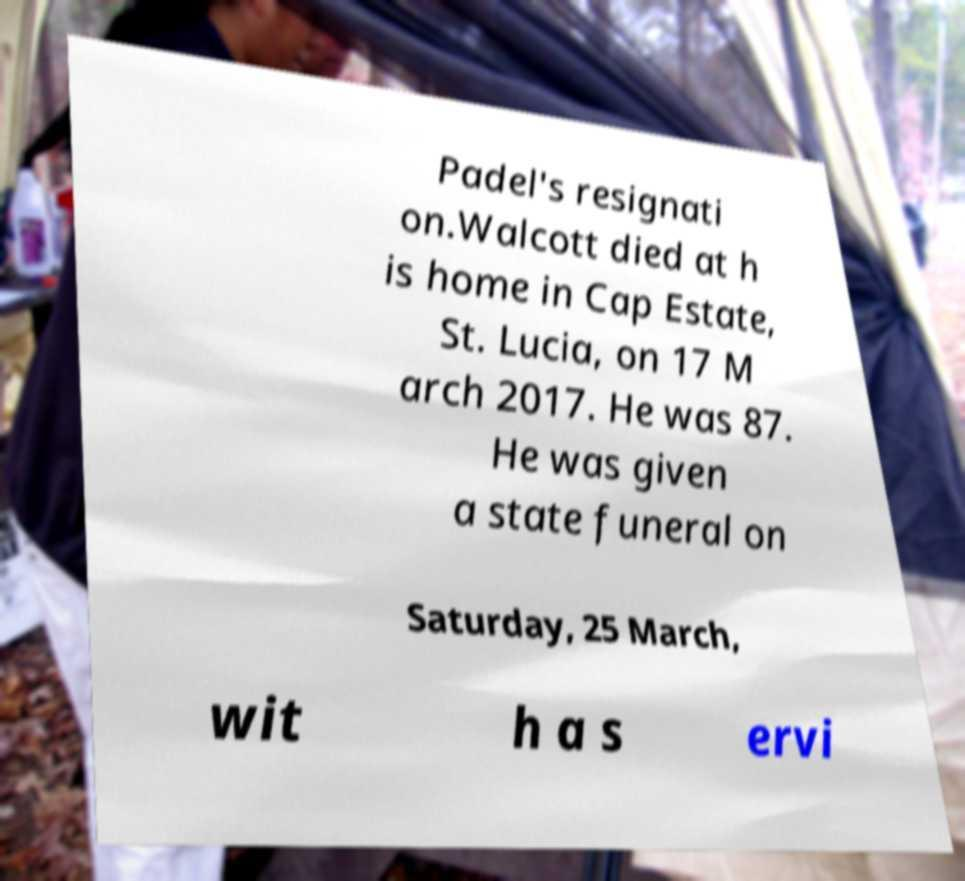Can you read and provide the text displayed in the image?This photo seems to have some interesting text. Can you extract and type it out for me? Padel's resignati on.Walcott died at h is home in Cap Estate, St. Lucia, on 17 M arch 2017. He was 87. He was given a state funeral on Saturday, 25 March, wit h a s ervi 